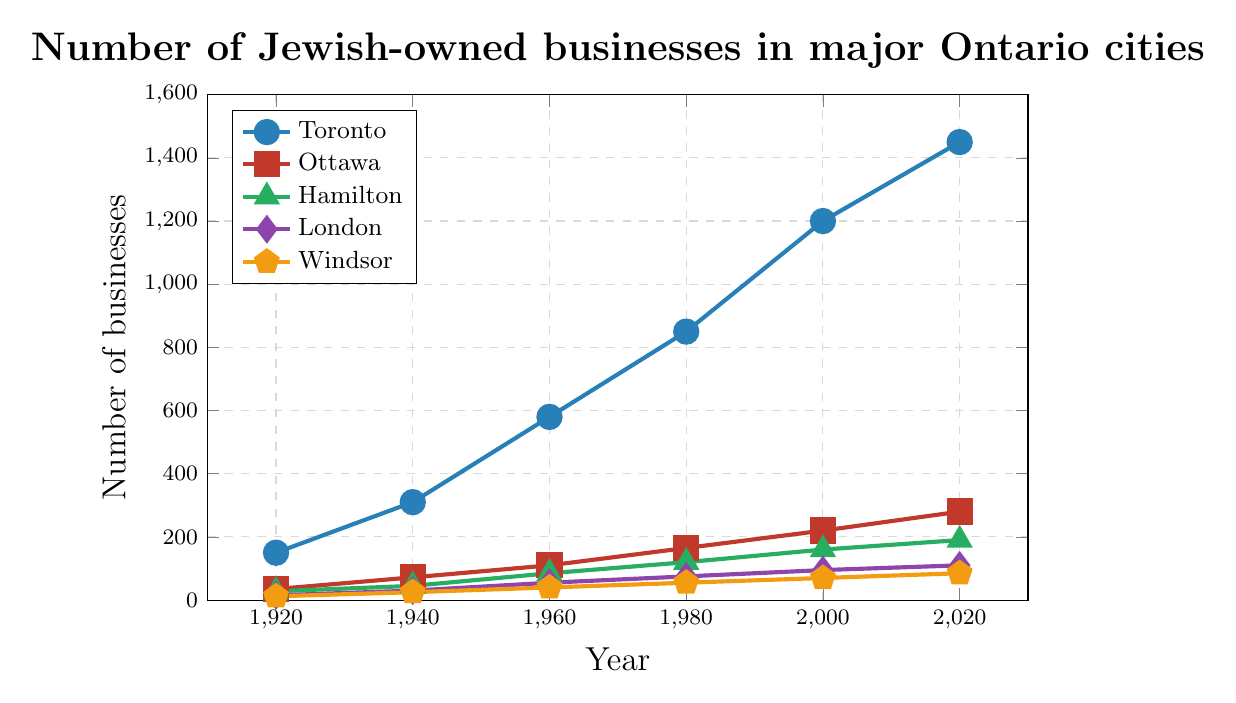What is the difference in the number of Jewish-owned businesses in Toronto between 1920 and 2000? To find the difference, subtract the number of businesses in 1920 from the number in 2000: 1200 - 150 = 1050.
Answer: 1050 Which city had the highest number of Jewish-owned businesses in 2020? Look at the 2020 data points for all cities; Toronto has the highest value at 1450.
Answer: Toronto How many Jewish-owned businesses were there in Hamilton in 1940 compared to Windsor in the same year? Hamilton had 45 businesses, and Windsor had 25 businesses in 1940. Compare 45 and 25.
Answer: Hamilton had 20 more businesses than Windsor What is the average number of Jewish-owned businesses in Ottawa over the entire century? Sum all the values for Ottawa, then divide by the number of data points: (35 + 72 + 110 + 165 + 220 + 280) / 6 = 882 / 6 = 147
Answer: 147 Which two cities had the closest numbers of Jewish-owned businesses in 1980? Check the 1980 values for all cities: Toronto (850), Ottawa (165), Hamilton (120), London (75), Windsor (55). Hamilton and London are the closest with 120 and 75, respectively.
Answer: Hamilton and London What is the overall trend for Jewish-owned businesses in London between 1920 and 2020? Observe the data points for London: From 15 in 1920, 30 in 1940, 55 in 1960, 75 in 1980, 95 in 2000, and 110 in 2020. The trend shows a steady increase over time.
Answer: Increasing trend In which year did Ottawa first surpass 100 Jewish-owned businesses? Look at the values for Ottawa over the years. Ottawa passed 100 businesses in the year 1960 with 110 businesses.
Answer: 1960 What was the % increase in Jewish-owned businesses in Windsor from 1920 to 2020? Calculate the percentage increase: ((85 - 12) / 12) * 100 = (73 / 12) * 100 ≈ 608.33%.
Answer: 608.33% 